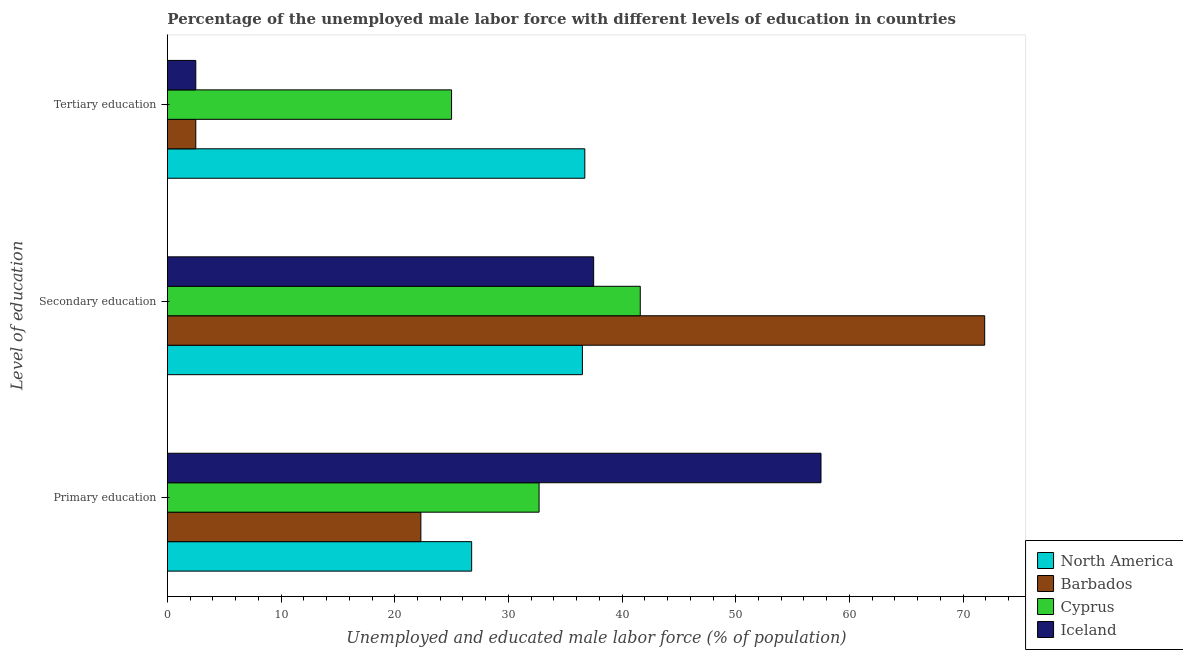Are the number of bars per tick equal to the number of legend labels?
Your response must be concise. Yes. Are the number of bars on each tick of the Y-axis equal?
Your answer should be compact. Yes. How many bars are there on the 3rd tick from the bottom?
Provide a short and direct response. 4. What is the label of the 2nd group of bars from the top?
Offer a very short reply. Secondary education. What is the percentage of male labor force who received primary education in Cyprus?
Your answer should be compact. 32.7. Across all countries, what is the maximum percentage of male labor force who received primary education?
Make the answer very short. 57.5. In which country was the percentage of male labor force who received secondary education maximum?
Make the answer very short. Barbados. In which country was the percentage of male labor force who received tertiary education minimum?
Provide a succinct answer. Barbados. What is the total percentage of male labor force who received secondary education in the graph?
Give a very brief answer. 187.51. What is the difference between the percentage of male labor force who received secondary education in North America and that in Iceland?
Make the answer very short. -0.99. What is the difference between the percentage of male labor force who received primary education in Barbados and the percentage of male labor force who received secondary education in North America?
Offer a terse response. -14.21. What is the average percentage of male labor force who received secondary education per country?
Ensure brevity in your answer.  46.88. What is the difference between the percentage of male labor force who received primary education and percentage of male labor force who received tertiary education in Barbados?
Make the answer very short. 19.8. What is the ratio of the percentage of male labor force who received tertiary education in Iceland to that in Cyprus?
Keep it short and to the point. 0.1. Is the percentage of male labor force who received primary education in Iceland less than that in Barbados?
Provide a short and direct response. No. Is the difference between the percentage of male labor force who received secondary education in Cyprus and Barbados greater than the difference between the percentage of male labor force who received primary education in Cyprus and Barbados?
Make the answer very short. No. What is the difference between the highest and the second highest percentage of male labor force who received tertiary education?
Ensure brevity in your answer.  11.72. What is the difference between the highest and the lowest percentage of male labor force who received tertiary education?
Keep it short and to the point. 34.22. Is the sum of the percentage of male labor force who received tertiary education in Cyprus and North America greater than the maximum percentage of male labor force who received secondary education across all countries?
Offer a terse response. No. What does the 2nd bar from the top in Tertiary education represents?
Provide a short and direct response. Cyprus. What does the 4th bar from the bottom in Primary education represents?
Make the answer very short. Iceland. How many countries are there in the graph?
Your answer should be very brief. 4. What is the difference between two consecutive major ticks on the X-axis?
Provide a short and direct response. 10. Does the graph contain any zero values?
Your answer should be compact. No. Does the graph contain grids?
Provide a succinct answer. No. How many legend labels are there?
Give a very brief answer. 4. What is the title of the graph?
Provide a short and direct response. Percentage of the unemployed male labor force with different levels of education in countries. What is the label or title of the X-axis?
Your response must be concise. Unemployed and educated male labor force (% of population). What is the label or title of the Y-axis?
Provide a succinct answer. Level of education. What is the Unemployed and educated male labor force (% of population) in North America in Primary education?
Give a very brief answer. 26.77. What is the Unemployed and educated male labor force (% of population) of Barbados in Primary education?
Provide a succinct answer. 22.3. What is the Unemployed and educated male labor force (% of population) in Cyprus in Primary education?
Provide a short and direct response. 32.7. What is the Unemployed and educated male labor force (% of population) in Iceland in Primary education?
Your answer should be compact. 57.5. What is the Unemployed and educated male labor force (% of population) of North America in Secondary education?
Make the answer very short. 36.51. What is the Unemployed and educated male labor force (% of population) in Barbados in Secondary education?
Your response must be concise. 71.9. What is the Unemployed and educated male labor force (% of population) in Cyprus in Secondary education?
Provide a succinct answer. 41.6. What is the Unemployed and educated male labor force (% of population) in Iceland in Secondary education?
Your answer should be very brief. 37.5. What is the Unemployed and educated male labor force (% of population) of North America in Tertiary education?
Ensure brevity in your answer.  36.72. What is the Unemployed and educated male labor force (% of population) in Barbados in Tertiary education?
Your answer should be very brief. 2.5. Across all Level of education, what is the maximum Unemployed and educated male labor force (% of population) in North America?
Ensure brevity in your answer.  36.72. Across all Level of education, what is the maximum Unemployed and educated male labor force (% of population) in Barbados?
Make the answer very short. 71.9. Across all Level of education, what is the maximum Unemployed and educated male labor force (% of population) of Cyprus?
Your response must be concise. 41.6. Across all Level of education, what is the maximum Unemployed and educated male labor force (% of population) of Iceland?
Provide a short and direct response. 57.5. Across all Level of education, what is the minimum Unemployed and educated male labor force (% of population) in North America?
Offer a very short reply. 26.77. Across all Level of education, what is the minimum Unemployed and educated male labor force (% of population) in Barbados?
Make the answer very short. 2.5. Across all Level of education, what is the minimum Unemployed and educated male labor force (% of population) in Cyprus?
Your answer should be very brief. 25. Across all Level of education, what is the minimum Unemployed and educated male labor force (% of population) of Iceland?
Your answer should be compact. 2.5. What is the total Unemployed and educated male labor force (% of population) of Barbados in the graph?
Your response must be concise. 96.7. What is the total Unemployed and educated male labor force (% of population) of Cyprus in the graph?
Make the answer very short. 99.3. What is the total Unemployed and educated male labor force (% of population) in Iceland in the graph?
Your answer should be very brief. 97.5. What is the difference between the Unemployed and educated male labor force (% of population) of North America in Primary education and that in Secondary education?
Give a very brief answer. -9.74. What is the difference between the Unemployed and educated male labor force (% of population) in Barbados in Primary education and that in Secondary education?
Give a very brief answer. -49.6. What is the difference between the Unemployed and educated male labor force (% of population) of Iceland in Primary education and that in Secondary education?
Your response must be concise. 20. What is the difference between the Unemployed and educated male labor force (% of population) of North America in Primary education and that in Tertiary education?
Your answer should be compact. -9.95. What is the difference between the Unemployed and educated male labor force (% of population) of Barbados in Primary education and that in Tertiary education?
Offer a very short reply. 19.8. What is the difference between the Unemployed and educated male labor force (% of population) in Cyprus in Primary education and that in Tertiary education?
Keep it short and to the point. 7.7. What is the difference between the Unemployed and educated male labor force (% of population) of North America in Secondary education and that in Tertiary education?
Keep it short and to the point. -0.21. What is the difference between the Unemployed and educated male labor force (% of population) in Barbados in Secondary education and that in Tertiary education?
Ensure brevity in your answer.  69.4. What is the difference between the Unemployed and educated male labor force (% of population) in North America in Primary education and the Unemployed and educated male labor force (% of population) in Barbados in Secondary education?
Offer a terse response. -45.13. What is the difference between the Unemployed and educated male labor force (% of population) of North America in Primary education and the Unemployed and educated male labor force (% of population) of Cyprus in Secondary education?
Your answer should be compact. -14.83. What is the difference between the Unemployed and educated male labor force (% of population) in North America in Primary education and the Unemployed and educated male labor force (% of population) in Iceland in Secondary education?
Your answer should be compact. -10.73. What is the difference between the Unemployed and educated male labor force (% of population) of Barbados in Primary education and the Unemployed and educated male labor force (% of population) of Cyprus in Secondary education?
Keep it short and to the point. -19.3. What is the difference between the Unemployed and educated male labor force (% of population) in Barbados in Primary education and the Unemployed and educated male labor force (% of population) in Iceland in Secondary education?
Provide a succinct answer. -15.2. What is the difference between the Unemployed and educated male labor force (% of population) in Cyprus in Primary education and the Unemployed and educated male labor force (% of population) in Iceland in Secondary education?
Your answer should be compact. -4.8. What is the difference between the Unemployed and educated male labor force (% of population) in North America in Primary education and the Unemployed and educated male labor force (% of population) in Barbados in Tertiary education?
Provide a short and direct response. 24.27. What is the difference between the Unemployed and educated male labor force (% of population) of North America in Primary education and the Unemployed and educated male labor force (% of population) of Cyprus in Tertiary education?
Give a very brief answer. 1.77. What is the difference between the Unemployed and educated male labor force (% of population) in North America in Primary education and the Unemployed and educated male labor force (% of population) in Iceland in Tertiary education?
Your answer should be very brief. 24.27. What is the difference between the Unemployed and educated male labor force (% of population) in Barbados in Primary education and the Unemployed and educated male labor force (% of population) in Iceland in Tertiary education?
Your answer should be compact. 19.8. What is the difference between the Unemployed and educated male labor force (% of population) of Cyprus in Primary education and the Unemployed and educated male labor force (% of population) of Iceland in Tertiary education?
Your answer should be compact. 30.2. What is the difference between the Unemployed and educated male labor force (% of population) in North America in Secondary education and the Unemployed and educated male labor force (% of population) in Barbados in Tertiary education?
Provide a succinct answer. 34.01. What is the difference between the Unemployed and educated male labor force (% of population) of North America in Secondary education and the Unemployed and educated male labor force (% of population) of Cyprus in Tertiary education?
Offer a terse response. 11.51. What is the difference between the Unemployed and educated male labor force (% of population) in North America in Secondary education and the Unemployed and educated male labor force (% of population) in Iceland in Tertiary education?
Your answer should be compact. 34.01. What is the difference between the Unemployed and educated male labor force (% of population) of Barbados in Secondary education and the Unemployed and educated male labor force (% of population) of Cyprus in Tertiary education?
Keep it short and to the point. 46.9. What is the difference between the Unemployed and educated male labor force (% of population) in Barbados in Secondary education and the Unemployed and educated male labor force (% of population) in Iceland in Tertiary education?
Give a very brief answer. 69.4. What is the difference between the Unemployed and educated male labor force (% of population) of Cyprus in Secondary education and the Unemployed and educated male labor force (% of population) of Iceland in Tertiary education?
Offer a very short reply. 39.1. What is the average Unemployed and educated male labor force (% of population) in North America per Level of education?
Offer a very short reply. 33.33. What is the average Unemployed and educated male labor force (% of population) of Barbados per Level of education?
Offer a terse response. 32.23. What is the average Unemployed and educated male labor force (% of population) in Cyprus per Level of education?
Your response must be concise. 33.1. What is the average Unemployed and educated male labor force (% of population) in Iceland per Level of education?
Your answer should be compact. 32.5. What is the difference between the Unemployed and educated male labor force (% of population) of North America and Unemployed and educated male labor force (% of population) of Barbados in Primary education?
Provide a short and direct response. 4.47. What is the difference between the Unemployed and educated male labor force (% of population) of North America and Unemployed and educated male labor force (% of population) of Cyprus in Primary education?
Provide a succinct answer. -5.93. What is the difference between the Unemployed and educated male labor force (% of population) in North America and Unemployed and educated male labor force (% of population) in Iceland in Primary education?
Provide a short and direct response. -30.73. What is the difference between the Unemployed and educated male labor force (% of population) in Barbados and Unemployed and educated male labor force (% of population) in Cyprus in Primary education?
Your answer should be compact. -10.4. What is the difference between the Unemployed and educated male labor force (% of population) of Barbados and Unemployed and educated male labor force (% of population) of Iceland in Primary education?
Offer a very short reply. -35.2. What is the difference between the Unemployed and educated male labor force (% of population) in Cyprus and Unemployed and educated male labor force (% of population) in Iceland in Primary education?
Provide a short and direct response. -24.8. What is the difference between the Unemployed and educated male labor force (% of population) of North America and Unemployed and educated male labor force (% of population) of Barbados in Secondary education?
Give a very brief answer. -35.39. What is the difference between the Unemployed and educated male labor force (% of population) of North America and Unemployed and educated male labor force (% of population) of Cyprus in Secondary education?
Ensure brevity in your answer.  -5.09. What is the difference between the Unemployed and educated male labor force (% of population) of North America and Unemployed and educated male labor force (% of population) of Iceland in Secondary education?
Your answer should be compact. -0.99. What is the difference between the Unemployed and educated male labor force (% of population) in Barbados and Unemployed and educated male labor force (% of population) in Cyprus in Secondary education?
Offer a terse response. 30.3. What is the difference between the Unemployed and educated male labor force (% of population) in Barbados and Unemployed and educated male labor force (% of population) in Iceland in Secondary education?
Give a very brief answer. 34.4. What is the difference between the Unemployed and educated male labor force (% of population) in Cyprus and Unemployed and educated male labor force (% of population) in Iceland in Secondary education?
Your response must be concise. 4.1. What is the difference between the Unemployed and educated male labor force (% of population) in North America and Unemployed and educated male labor force (% of population) in Barbados in Tertiary education?
Your answer should be very brief. 34.22. What is the difference between the Unemployed and educated male labor force (% of population) of North America and Unemployed and educated male labor force (% of population) of Cyprus in Tertiary education?
Make the answer very short. 11.72. What is the difference between the Unemployed and educated male labor force (% of population) of North America and Unemployed and educated male labor force (% of population) of Iceland in Tertiary education?
Provide a succinct answer. 34.22. What is the difference between the Unemployed and educated male labor force (% of population) of Barbados and Unemployed and educated male labor force (% of population) of Cyprus in Tertiary education?
Keep it short and to the point. -22.5. What is the difference between the Unemployed and educated male labor force (% of population) of Barbados and Unemployed and educated male labor force (% of population) of Iceland in Tertiary education?
Make the answer very short. 0. What is the difference between the Unemployed and educated male labor force (% of population) of Cyprus and Unemployed and educated male labor force (% of population) of Iceland in Tertiary education?
Your answer should be compact. 22.5. What is the ratio of the Unemployed and educated male labor force (% of population) in North America in Primary education to that in Secondary education?
Provide a succinct answer. 0.73. What is the ratio of the Unemployed and educated male labor force (% of population) of Barbados in Primary education to that in Secondary education?
Your answer should be very brief. 0.31. What is the ratio of the Unemployed and educated male labor force (% of population) in Cyprus in Primary education to that in Secondary education?
Your response must be concise. 0.79. What is the ratio of the Unemployed and educated male labor force (% of population) in Iceland in Primary education to that in Secondary education?
Your answer should be very brief. 1.53. What is the ratio of the Unemployed and educated male labor force (% of population) of North America in Primary education to that in Tertiary education?
Make the answer very short. 0.73. What is the ratio of the Unemployed and educated male labor force (% of population) in Barbados in Primary education to that in Tertiary education?
Your response must be concise. 8.92. What is the ratio of the Unemployed and educated male labor force (% of population) of Cyprus in Primary education to that in Tertiary education?
Make the answer very short. 1.31. What is the ratio of the Unemployed and educated male labor force (% of population) of Barbados in Secondary education to that in Tertiary education?
Keep it short and to the point. 28.76. What is the ratio of the Unemployed and educated male labor force (% of population) in Cyprus in Secondary education to that in Tertiary education?
Offer a very short reply. 1.66. What is the ratio of the Unemployed and educated male labor force (% of population) of Iceland in Secondary education to that in Tertiary education?
Offer a very short reply. 15. What is the difference between the highest and the second highest Unemployed and educated male labor force (% of population) of North America?
Offer a very short reply. 0.21. What is the difference between the highest and the second highest Unemployed and educated male labor force (% of population) in Barbados?
Offer a very short reply. 49.6. What is the difference between the highest and the lowest Unemployed and educated male labor force (% of population) of North America?
Offer a terse response. 9.95. What is the difference between the highest and the lowest Unemployed and educated male labor force (% of population) of Barbados?
Offer a very short reply. 69.4. What is the difference between the highest and the lowest Unemployed and educated male labor force (% of population) of Cyprus?
Your answer should be very brief. 16.6. What is the difference between the highest and the lowest Unemployed and educated male labor force (% of population) of Iceland?
Offer a very short reply. 55. 